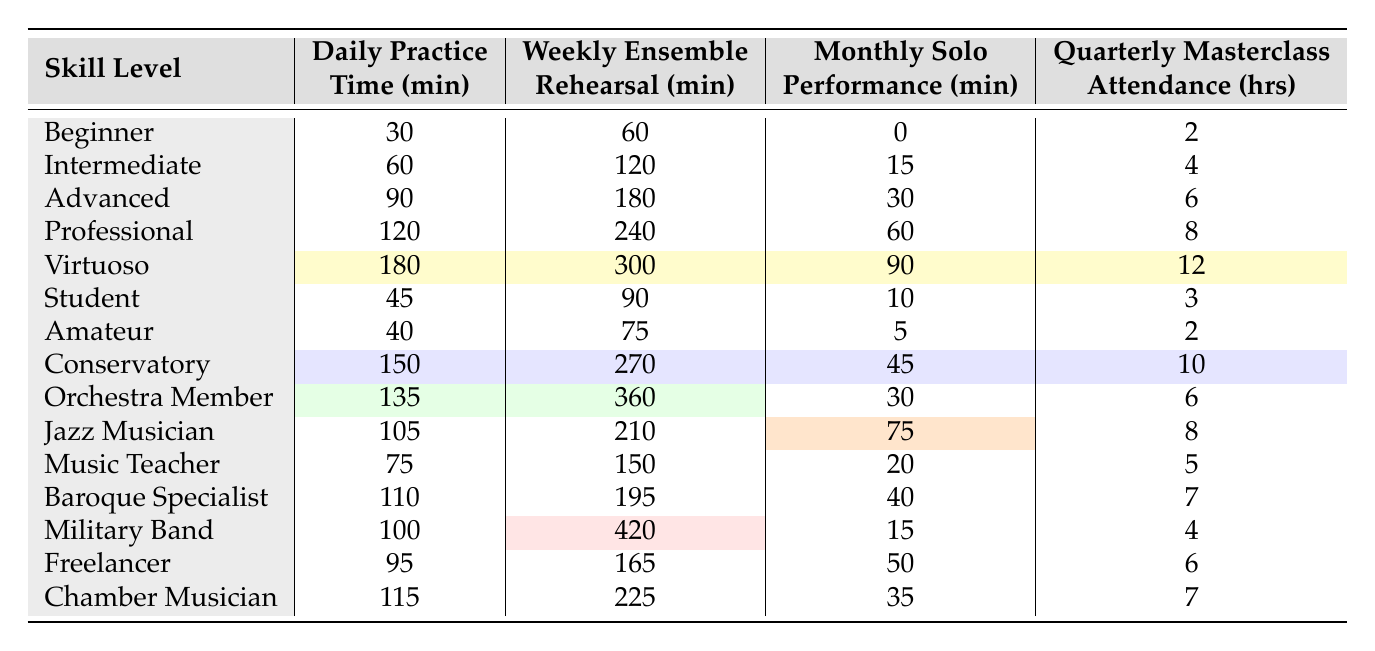What is the daily practice time for a Virtuoso trumpet player? According to the table, the daily practice time for a Virtuoso is listed as 180 minutes.
Answer: 180 minutes How much weekly ensemble rehearsal time does a Professional trumpet player spend? The table states that a Professional trumpet player spends 240 minutes in weekly ensemble rehearsals.
Answer: 240 minutes Which skill level has the highest monthly solo performance time? The Virtuoso trumpet player has the highest monthly solo performance time of 90 minutes, as seen in the table.
Answer: Virtuoso What is the average daily practice time for all trumpet players listed? To find the average, we sum up all daily practice times: 30 + 60 + 90 + 120 + 180 + 45 + 40 + 150 + 135 + 105 + 75 + 110 + 100 + 95 + 115 = 1545. There are 15 entries, so the average is 1545 / 15 = 103.
Answer: 103 minutes Is the weekly ensemble rehearsal time for an Amateur trumpet player greater than that of a Beginner? The table shows that the Amateur has 75 minutes for ensemble rehearsal, while the Beginner has 60 minutes, confirming that the Amateur's time is greater.
Answer: Yes What is the difference in monthly solo performance time between an Advanced and an Orchestra Member player? The Advanced player's monthly solo performance time is 30 minutes, while the Orchestra Member's is 30 minutes too. The difference is 30 - 30 = 0 minutes.
Answer: 0 minutes Which skill level has the minimum daily practice time, and how much is it? The Beginner skill level has the minimum daily practice time of 30 minutes, as indicated in the table.
Answer: Beginner, 30 minutes What total time does a Conservatory trumpet player spend on practicing per week when combining daily and ensemble rehearsal times? The Conservatory player practices 150 minutes daily and has 270 minutes for ensemble rehearsal. The total is 150 + 270 = 420 minutes.
Answer: 420 minutes Is it true that a Jazz Musician spends more time in monthly solo performances than a Military Band player? The Jazz Musician spends 75 minutes in monthly solo performances, whereas the Military Band player spends only 15 minutes, confirming the statement is true.
Answer: Yes What is the total amount of masterclass attendance time for a Baroque Specialist and a Freelancer when combined? The Baroque Specialist attends 7 hours of masterclasses, and the Freelancer attends 6 hours. Combined, the total is 7 + 6 = 13 hours.
Answer: 13 hours 